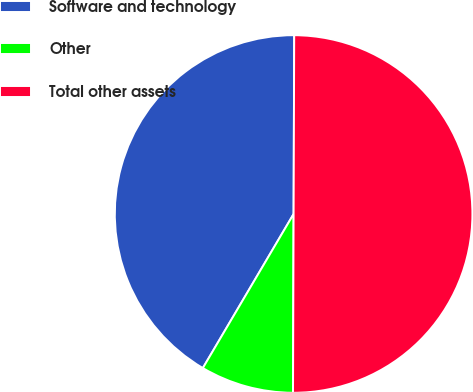Convert chart to OTSL. <chart><loc_0><loc_0><loc_500><loc_500><pie_chart><fcel>Software and technology<fcel>Other<fcel>Total other assets<nl><fcel>41.58%<fcel>8.42%<fcel>50.0%<nl></chart> 